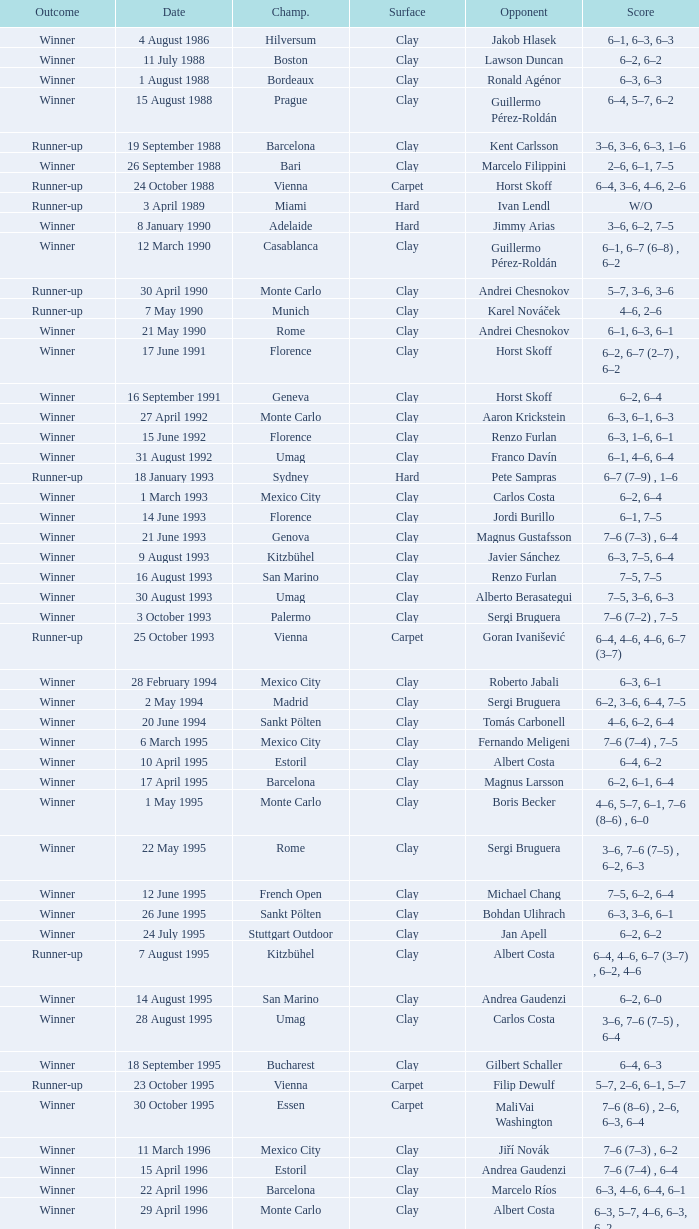Who is the opponent on 18 january 1993? Pete Sampras. 